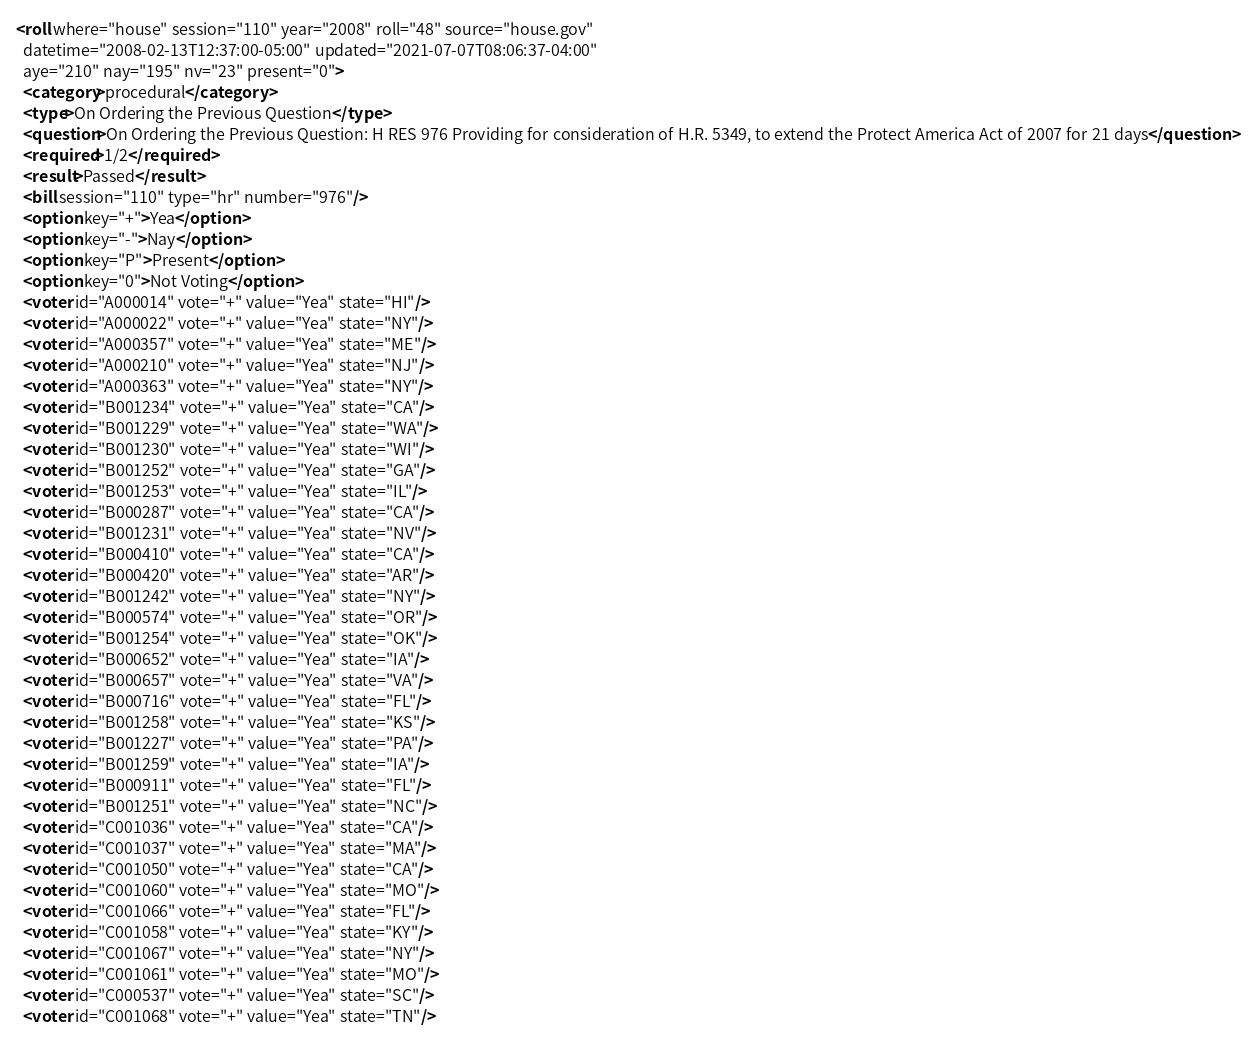<code> <loc_0><loc_0><loc_500><loc_500><_XML_><roll where="house" session="110" year="2008" roll="48" source="house.gov"
  datetime="2008-02-13T12:37:00-05:00" updated="2021-07-07T08:06:37-04:00"
  aye="210" nay="195" nv="23" present="0">
  <category>procedural</category>
  <type>On Ordering the Previous Question</type>
  <question>On Ordering the Previous Question: H RES 976 Providing for consideration of H.R. 5349, to extend the Protect America Act of 2007 for 21 days</question>
  <required>1/2</required>
  <result>Passed</result>
  <bill session="110" type="hr" number="976"/>
  <option key="+">Yea</option>
  <option key="-">Nay</option>
  <option key="P">Present</option>
  <option key="0">Not Voting</option>
  <voter id="A000014" vote="+" value="Yea" state="HI"/>
  <voter id="A000022" vote="+" value="Yea" state="NY"/>
  <voter id="A000357" vote="+" value="Yea" state="ME"/>
  <voter id="A000210" vote="+" value="Yea" state="NJ"/>
  <voter id="A000363" vote="+" value="Yea" state="NY"/>
  <voter id="B001234" vote="+" value="Yea" state="CA"/>
  <voter id="B001229" vote="+" value="Yea" state="WA"/>
  <voter id="B001230" vote="+" value="Yea" state="WI"/>
  <voter id="B001252" vote="+" value="Yea" state="GA"/>
  <voter id="B001253" vote="+" value="Yea" state="IL"/>
  <voter id="B000287" vote="+" value="Yea" state="CA"/>
  <voter id="B001231" vote="+" value="Yea" state="NV"/>
  <voter id="B000410" vote="+" value="Yea" state="CA"/>
  <voter id="B000420" vote="+" value="Yea" state="AR"/>
  <voter id="B001242" vote="+" value="Yea" state="NY"/>
  <voter id="B000574" vote="+" value="Yea" state="OR"/>
  <voter id="B001254" vote="+" value="Yea" state="OK"/>
  <voter id="B000652" vote="+" value="Yea" state="IA"/>
  <voter id="B000657" vote="+" value="Yea" state="VA"/>
  <voter id="B000716" vote="+" value="Yea" state="FL"/>
  <voter id="B001258" vote="+" value="Yea" state="KS"/>
  <voter id="B001227" vote="+" value="Yea" state="PA"/>
  <voter id="B001259" vote="+" value="Yea" state="IA"/>
  <voter id="B000911" vote="+" value="Yea" state="FL"/>
  <voter id="B001251" vote="+" value="Yea" state="NC"/>
  <voter id="C001036" vote="+" value="Yea" state="CA"/>
  <voter id="C001037" vote="+" value="Yea" state="MA"/>
  <voter id="C001050" vote="+" value="Yea" state="CA"/>
  <voter id="C001060" vote="+" value="Yea" state="MO"/>
  <voter id="C001066" vote="+" value="Yea" state="FL"/>
  <voter id="C001058" vote="+" value="Yea" state="KY"/>
  <voter id="C001067" vote="+" value="Yea" state="NY"/>
  <voter id="C001061" vote="+" value="Yea" state="MO"/>
  <voter id="C000537" vote="+" value="Yea" state="SC"/>
  <voter id="C001068" vote="+" value="Yea" state="TN"/></code> 